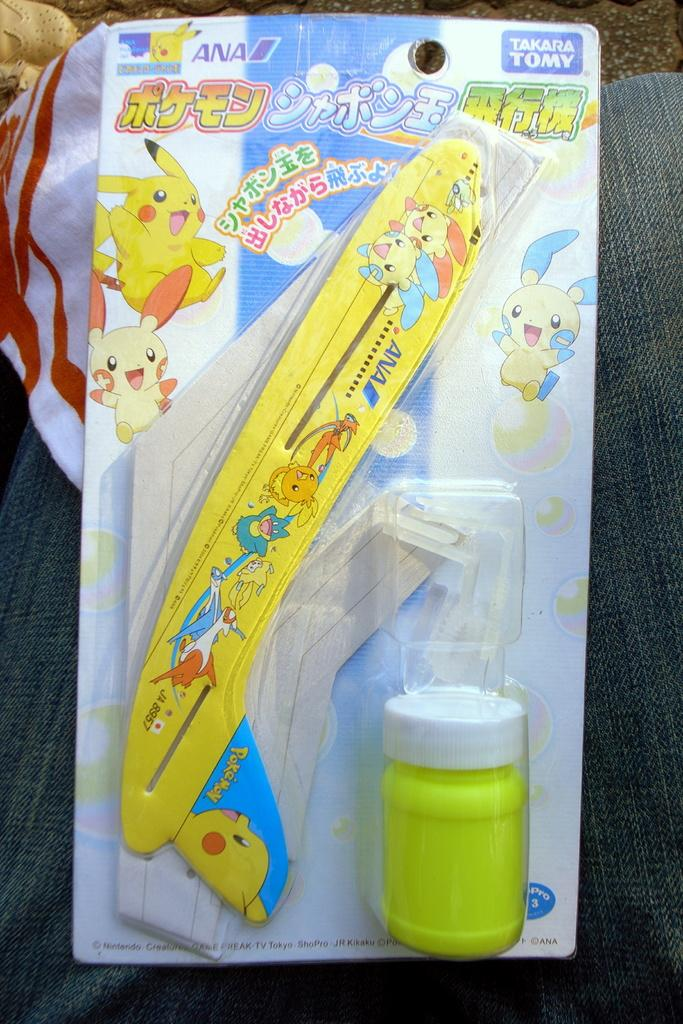What type of object can be seen in the image? There is a toy in the image. What material is present in the image? There is a cloth in the image. What type of images are featured in the image? Cartoon images are present in the image. What else can be seen in the image that contains text? There is text on a packet in the image. What type of nail is being hammered in the image? There is no nail or hammering activity present in the image. 